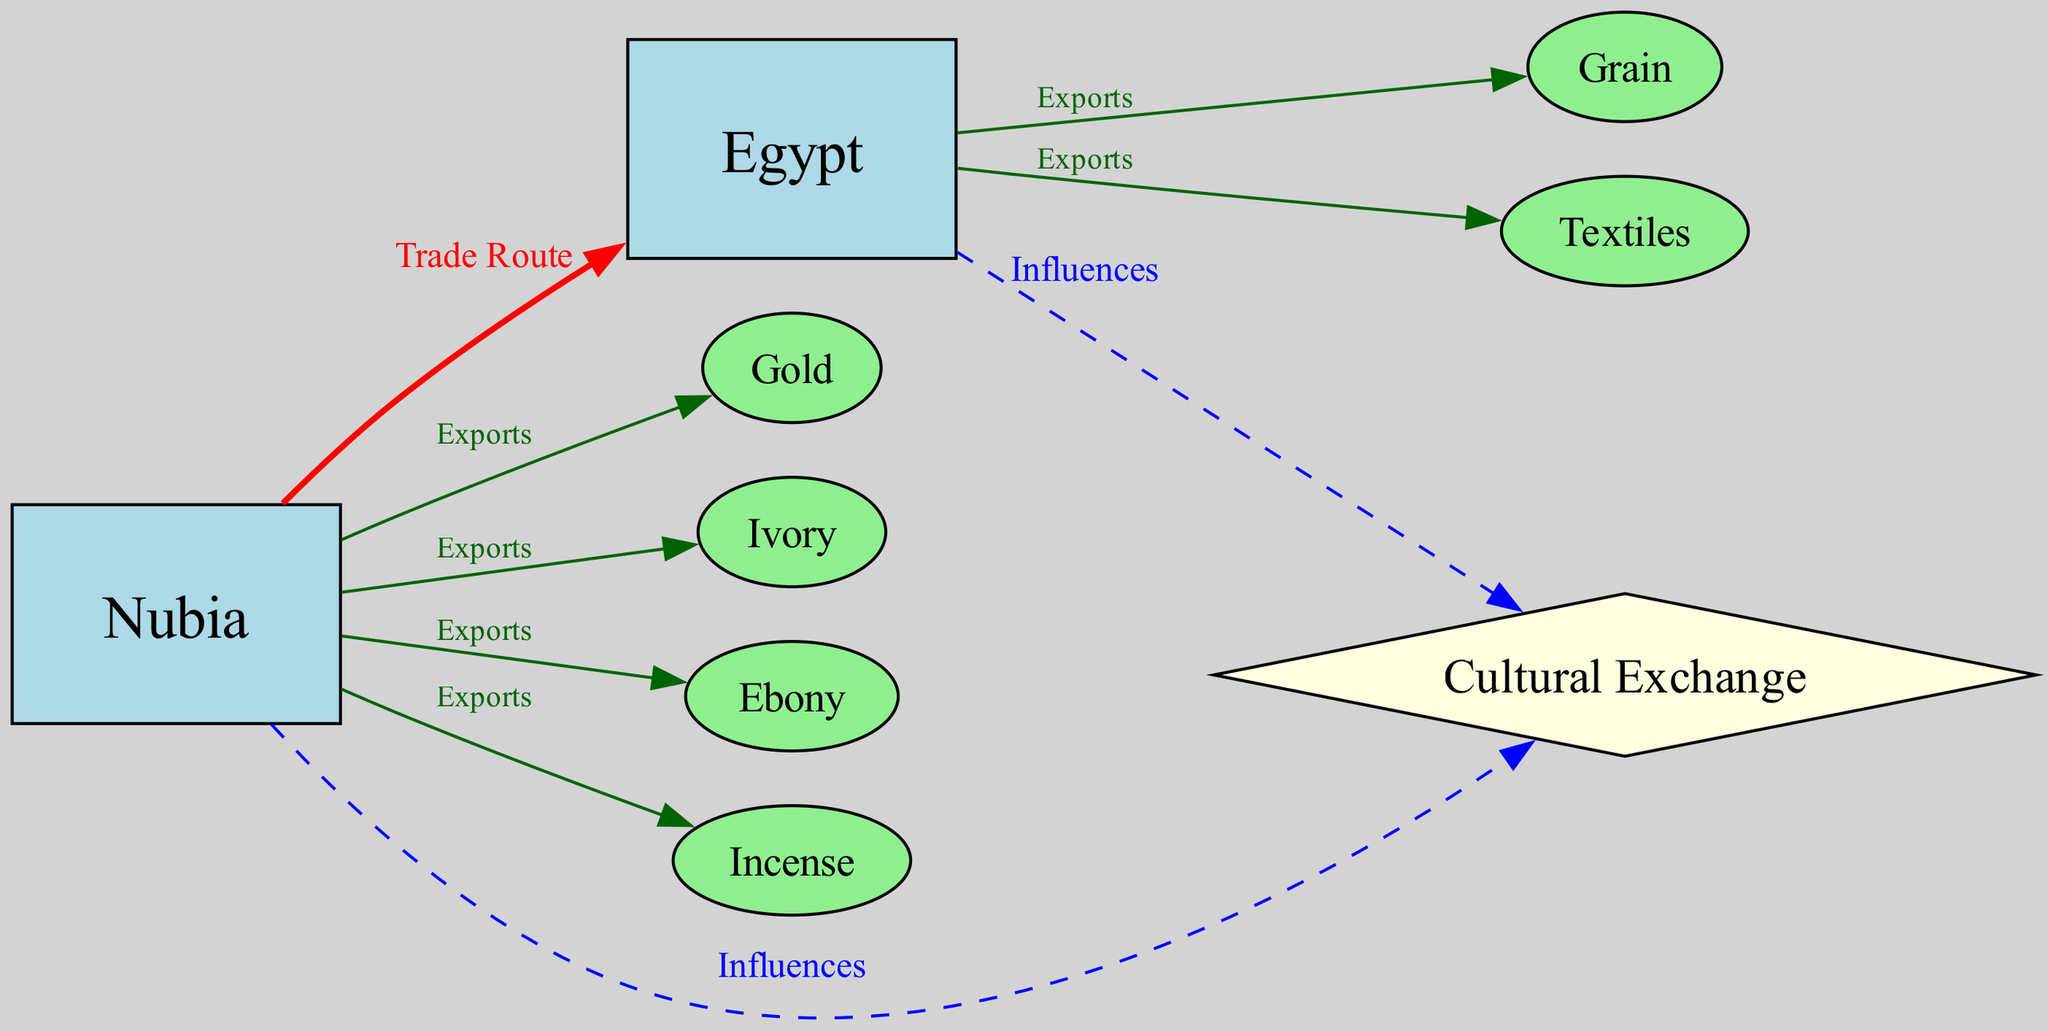What commodities does Nubia export to Egypt? The diagram shows that Nubia exports Gold, Ivory, Ebony, and Incense to Egypt. These commodities are listed as edges leading from the Nubia node.
Answer: Gold, Ivory, Ebony, Incense How many goods are exported from Nubia? By counting the edges originating from the Nubia node, we find there are four distinct commodities being exported to Egypt.
Answer: Four What does Egypt export to Nubia? The diagram indicates that Egypt exports Grain and Textiles to Nubia, as these are shown as edges coming out of the Egypt node.
Answer: Grain, Textiles What type of exchange is represented by the edges between Nubia and Egypt? The edges between Nubia and Egypt are labeled "Trade Route," indicating that these connections represent trade exchanges between the two regions.
Answer: Trade Route Which color represents the cultural exchange in the diagram? Cultural exchange influences are depicted with dashed blue edges, connecting both Nubia and Egypt nodes to the Cultural Exchange node.
Answer: Blue How many total nodes are in the diagram? By counting the nodes, including Nubia, Egypt, the commodities, and the cultural exchange, we find there are a total of nine nodes in the diagram.
Answer: Nine What are the two primary types of goods Nubia exports? Nubia exports luxury goods such as Gold, Ivory, and Ebony. These are marked as significant exports in the diagram.
Answer: Luxury goods Which entity influences cultural exchanges according to the diagram? The diagram shows that both Nubia and Egypt influence cultural exchanges, with connections from both nodes leading to the Cultural Exchange node.
Answer: Both Nubia and Egypt What is the relationship between Nubia and cultural exchange? Nubia influences cultural exchange, as shown by a connecting edge labeled "Influences" from Nubia to the Cultural Exchange node.
Answer: Influences 